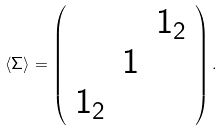<formula> <loc_0><loc_0><loc_500><loc_500>\langle \Sigma \rangle = \left ( \begin{array} { c c c } & & 1 _ { 2 } \\ & 1 \\ 1 _ { 2 } \\ \end{array} \right ) .</formula> 